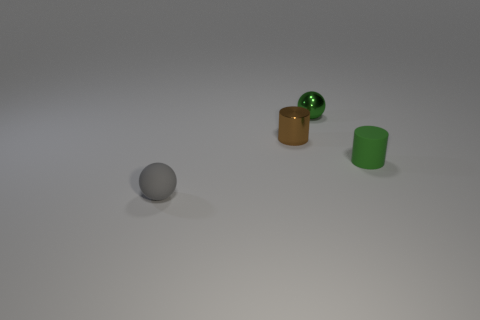What number of big things are cylinders or gray matte things?
Your answer should be very brief. 0. What number of other things are the same color as the tiny metal cylinder?
Offer a terse response. 0. How many matte balls are to the right of the tiny ball that is on the left side of the metallic object on the left side of the green metal thing?
Offer a terse response. 0. There is a rubber thing to the right of the gray ball; does it have the same size as the small brown object?
Give a very brief answer. Yes. Are there fewer gray things behind the gray thing than rubber balls that are behind the small green cylinder?
Give a very brief answer. No. Is the metal cylinder the same color as the small shiny ball?
Give a very brief answer. No. Are there fewer tiny rubber spheres on the left side of the small rubber cylinder than gray matte spheres?
Your answer should be compact. No. There is a tiny sphere that is the same color as the small matte cylinder; what material is it?
Your response must be concise. Metal. Do the green sphere and the gray thing have the same material?
Your answer should be very brief. No. How many cylinders are the same material as the tiny gray sphere?
Keep it short and to the point. 1. 